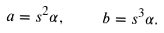Convert formula to latex. <formula><loc_0><loc_0><loc_500><loc_500>a = s ^ { 2 } \alpha , \quad b = s ^ { 3 } \alpha .</formula> 